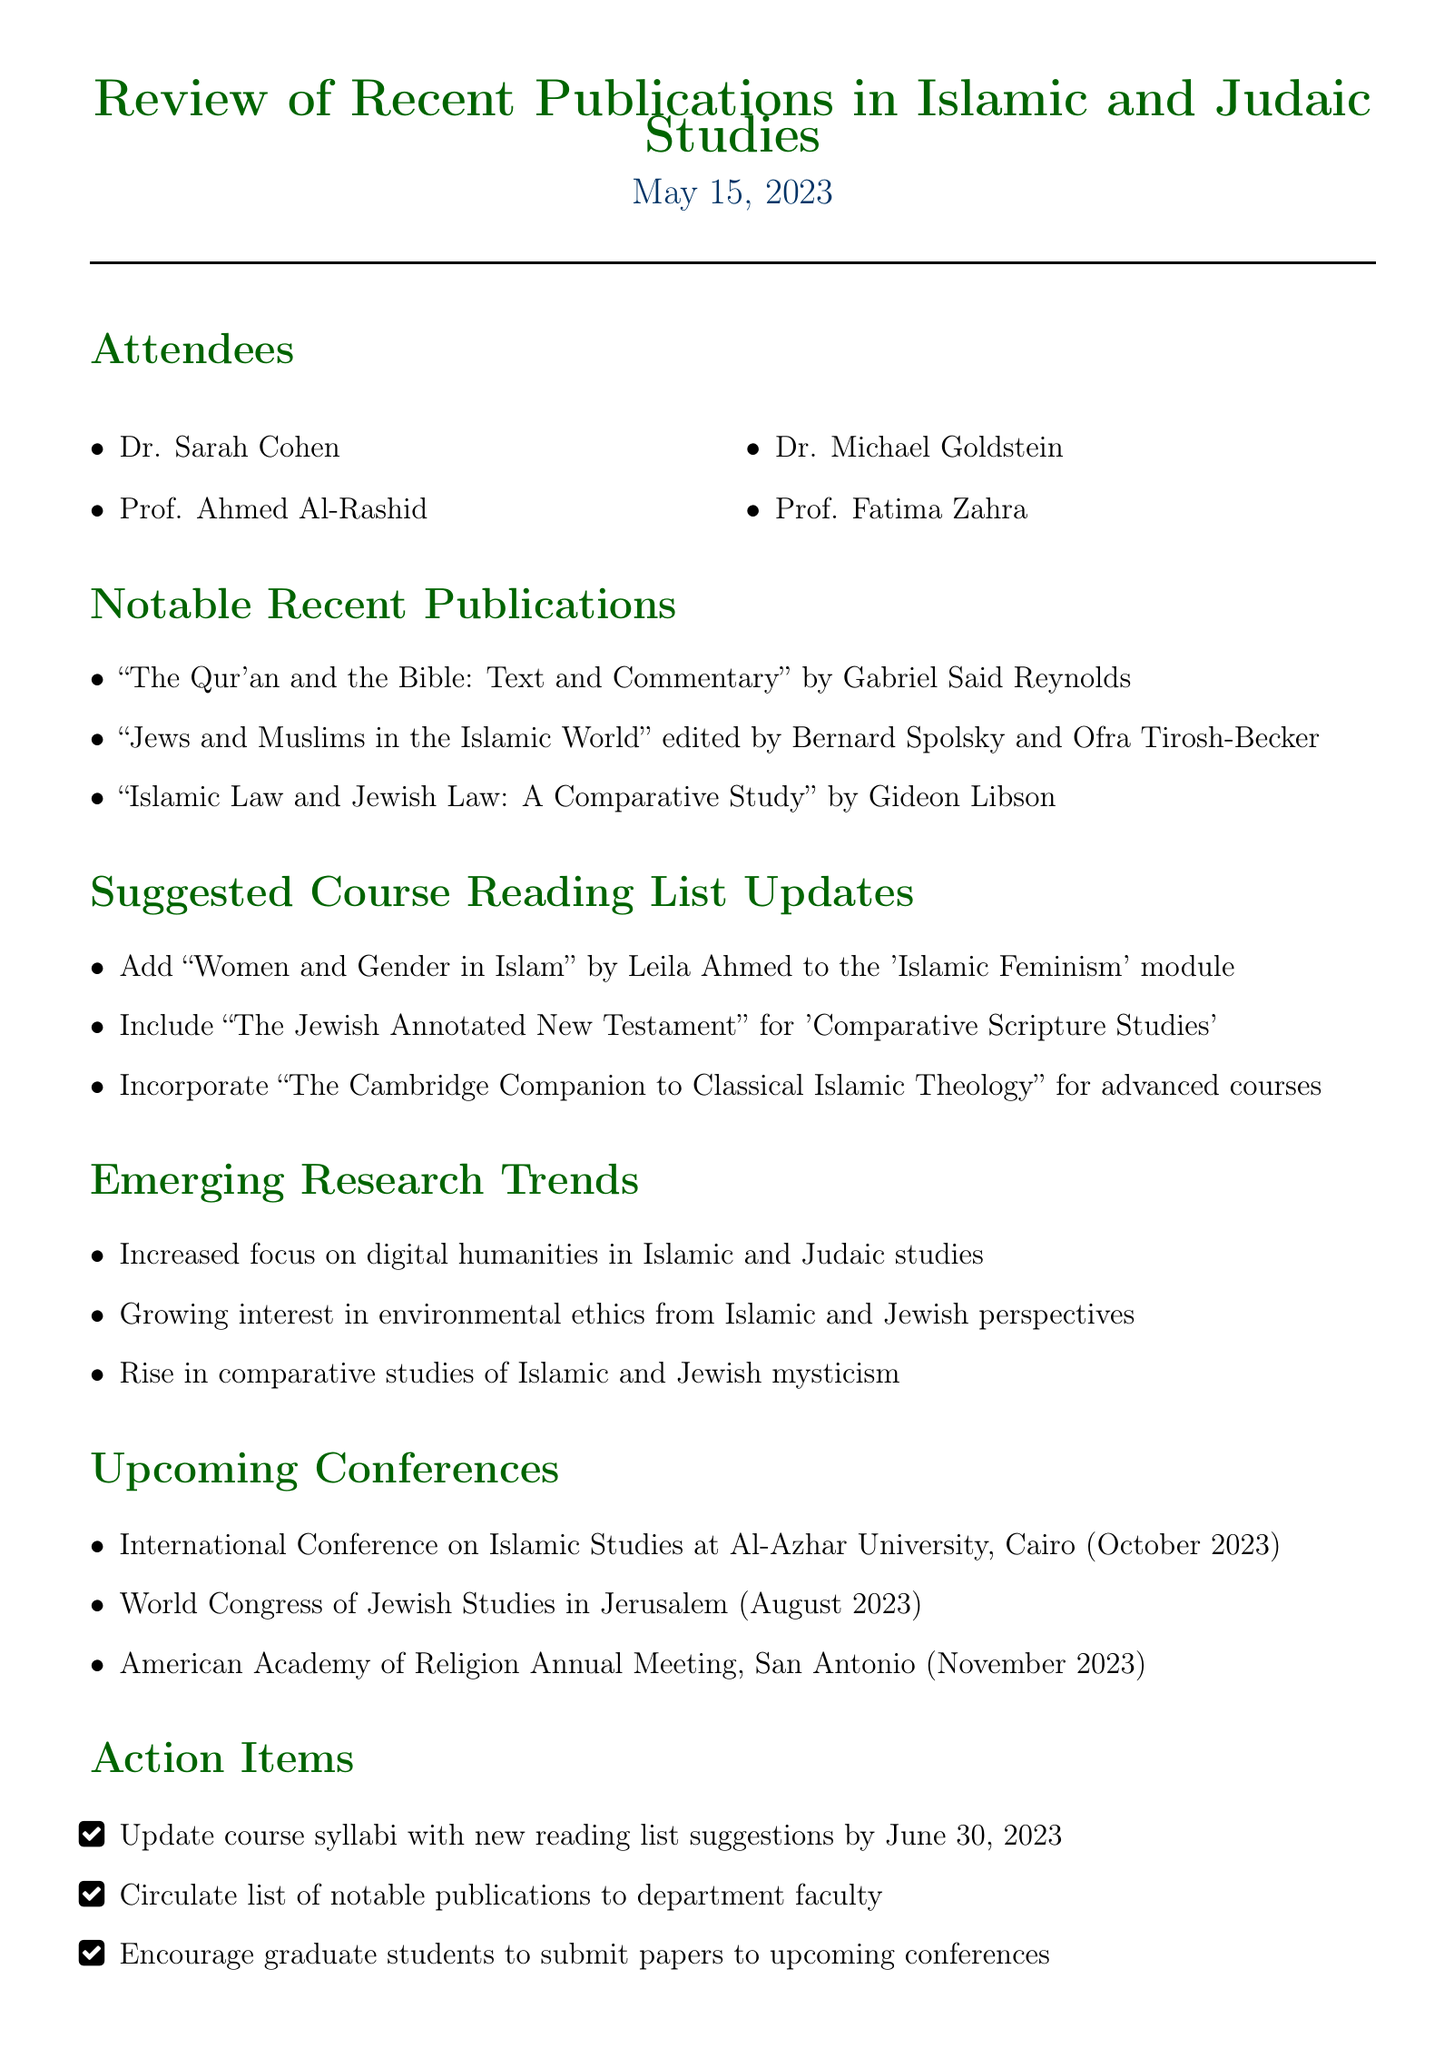What is the date of the meeting? The date of the meeting is mentioned in the document as May 15, 2023.
Answer: May 15, 2023 Who authored the publication titled "Islamic Law and Jewish Law: A Comparative Study"? The document lists Gideon Libson as the author of the publication.
Answer: Gideon Libson What is one of the suggested updates for the course reading list? The document specifies that "Women and Gender in Islam" by Leila Ahmed should be added to the 'Islamic Feminism' module.
Answer: Add "Women and Gender in Islam" What conference is scheduled for October 2023? The document mentions the International Conference on Islamic Studies at Al-Azhar University as the event scheduled for October 2023.
Answer: International Conference on Islamic Studies What is a noted emerging research trend in Islamic and Judaic studies? The document highlights an increased focus on digital humanities as an emerging research trend.
Answer: Digital humanities How many attendees were present at the meeting? The document lists four individuals who attended the meeting.
Answer: Four Which publication was edited by Amy-Jill Levine and Marc Zvi Brettler? The document states that "The Jewish Annotated New Testament" was edited by them.
Answer: The Jewish Annotated New Testament What is the deadline for updating course syllabi with the new reading list suggestions? The document specifies June 30, 2023, as the deadline for updating course syllabi.
Answer: June 30, 2023 What type of studies is rising according to the document? The document mentions a rise in comparative studies of Islamic and Jewish mysticism.
Answer: Comparative studies of Islamic and Jewish mysticism 